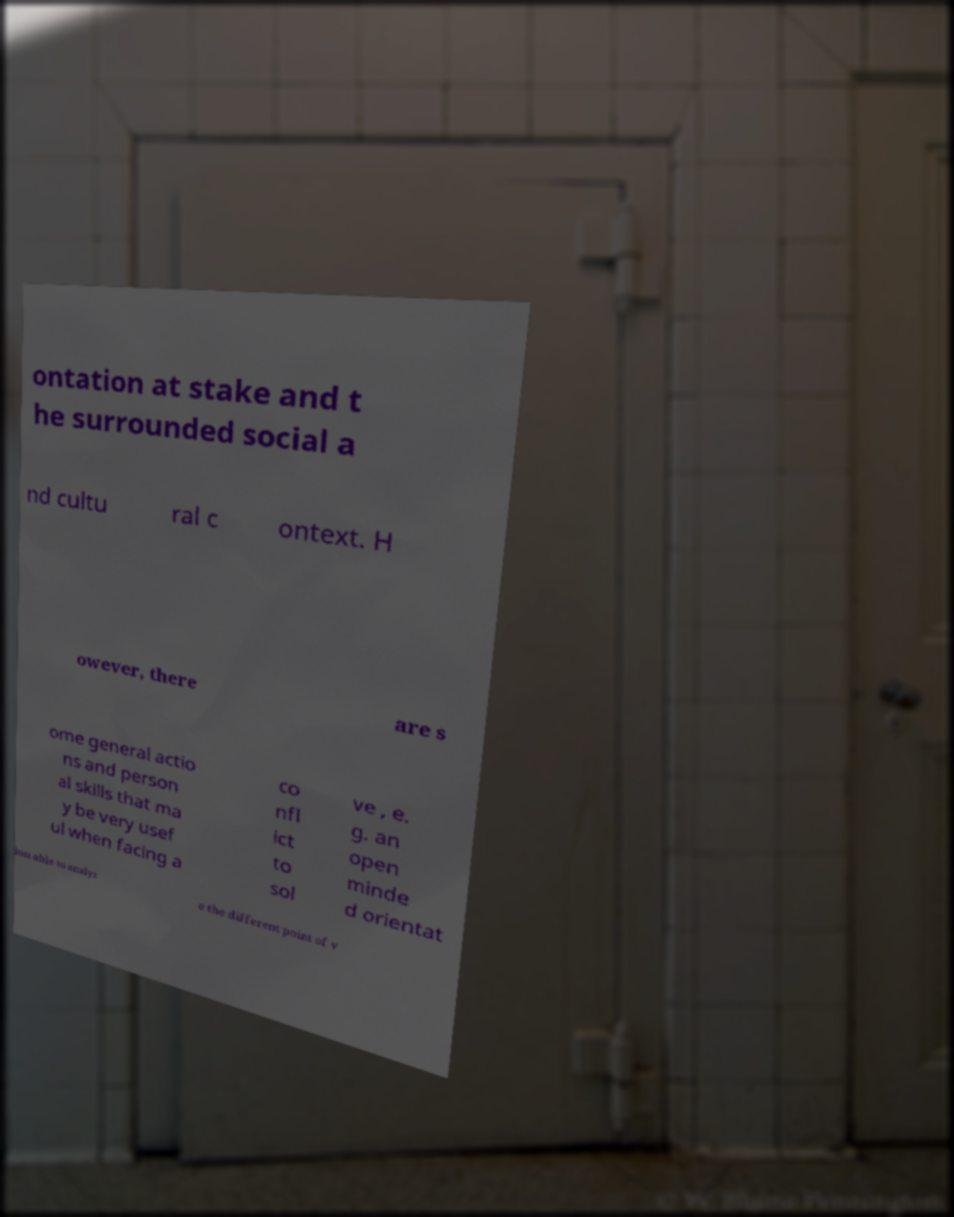Can you accurately transcribe the text from the provided image for me? ontation at stake and t he surrounded social a nd cultu ral c ontext. H owever, there are s ome general actio ns and person al skills that ma y be very usef ul when facing a co nfl ict to sol ve , e. g. an open minde d orientat ion able to analyz e the different point of v 